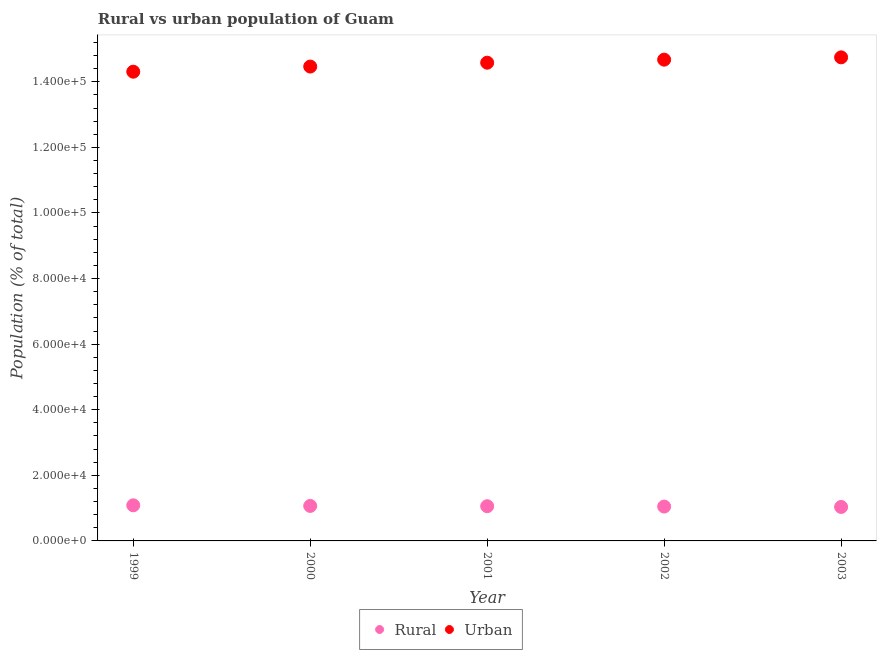What is the urban population density in 2001?
Give a very brief answer. 1.46e+05. Across all years, what is the maximum rural population density?
Ensure brevity in your answer.  1.09e+04. Across all years, what is the minimum urban population density?
Give a very brief answer. 1.43e+05. In which year was the urban population density maximum?
Make the answer very short. 2003. What is the total rural population density in the graph?
Make the answer very short. 5.30e+04. What is the difference between the rural population density in 2000 and that in 2002?
Offer a very short reply. 191. What is the difference between the rural population density in 2003 and the urban population density in 2001?
Your answer should be very brief. -1.35e+05. What is the average rural population density per year?
Offer a very short reply. 1.06e+04. In the year 2000, what is the difference between the urban population density and rural population density?
Your answer should be compact. 1.34e+05. In how many years, is the urban population density greater than 144000 %?
Offer a very short reply. 4. What is the ratio of the rural population density in 1999 to that in 2003?
Ensure brevity in your answer.  1.05. What is the difference between the highest and the second highest urban population density?
Provide a succinct answer. 703. What is the difference between the highest and the lowest urban population density?
Offer a very short reply. 4371. Is the sum of the urban population density in 1999 and 2003 greater than the maximum rural population density across all years?
Your response must be concise. Yes. Does the urban population density monotonically increase over the years?
Your answer should be very brief. Yes. Is the rural population density strictly less than the urban population density over the years?
Provide a succinct answer. Yes. How many years are there in the graph?
Make the answer very short. 5. What is the difference between two consecutive major ticks on the Y-axis?
Make the answer very short. 2.00e+04. Does the graph contain any zero values?
Make the answer very short. No. How are the legend labels stacked?
Offer a very short reply. Horizontal. What is the title of the graph?
Your answer should be very brief. Rural vs urban population of Guam. What is the label or title of the X-axis?
Give a very brief answer. Year. What is the label or title of the Y-axis?
Offer a very short reply. Population (% of total). What is the Population (% of total) in Rural in 1999?
Your answer should be very brief. 1.09e+04. What is the Population (% of total) of Urban in 1999?
Ensure brevity in your answer.  1.43e+05. What is the Population (% of total) in Rural in 2000?
Give a very brief answer. 1.07e+04. What is the Population (% of total) of Urban in 2000?
Give a very brief answer. 1.45e+05. What is the Population (% of total) of Rural in 2001?
Give a very brief answer. 1.06e+04. What is the Population (% of total) of Urban in 2001?
Provide a succinct answer. 1.46e+05. What is the Population (% of total) in Rural in 2002?
Provide a short and direct response. 1.05e+04. What is the Population (% of total) of Urban in 2002?
Ensure brevity in your answer.  1.47e+05. What is the Population (% of total) of Rural in 2003?
Ensure brevity in your answer.  1.04e+04. What is the Population (% of total) of Urban in 2003?
Your response must be concise. 1.47e+05. Across all years, what is the maximum Population (% of total) of Rural?
Offer a terse response. 1.09e+04. Across all years, what is the maximum Population (% of total) in Urban?
Provide a short and direct response. 1.47e+05. Across all years, what is the minimum Population (% of total) in Rural?
Give a very brief answer. 1.04e+04. Across all years, what is the minimum Population (% of total) of Urban?
Offer a very short reply. 1.43e+05. What is the total Population (% of total) in Rural in the graph?
Offer a very short reply. 5.30e+04. What is the total Population (% of total) in Urban in the graph?
Make the answer very short. 7.28e+05. What is the difference between the Population (% of total) of Rural in 1999 and that in 2000?
Make the answer very short. 187. What is the difference between the Population (% of total) in Urban in 1999 and that in 2000?
Make the answer very short. -1564. What is the difference between the Population (% of total) of Rural in 1999 and that in 2001?
Make the answer very short. 275. What is the difference between the Population (% of total) in Urban in 1999 and that in 2001?
Offer a terse response. -2741. What is the difference between the Population (% of total) of Rural in 1999 and that in 2002?
Provide a short and direct response. 378. What is the difference between the Population (% of total) of Urban in 1999 and that in 2002?
Ensure brevity in your answer.  -3668. What is the difference between the Population (% of total) of Rural in 1999 and that in 2003?
Your response must be concise. 499. What is the difference between the Population (% of total) of Urban in 1999 and that in 2003?
Provide a succinct answer. -4371. What is the difference between the Population (% of total) in Rural in 2000 and that in 2001?
Keep it short and to the point. 88. What is the difference between the Population (% of total) in Urban in 2000 and that in 2001?
Give a very brief answer. -1177. What is the difference between the Population (% of total) of Rural in 2000 and that in 2002?
Offer a terse response. 191. What is the difference between the Population (% of total) of Urban in 2000 and that in 2002?
Your answer should be compact. -2104. What is the difference between the Population (% of total) of Rural in 2000 and that in 2003?
Keep it short and to the point. 312. What is the difference between the Population (% of total) of Urban in 2000 and that in 2003?
Ensure brevity in your answer.  -2807. What is the difference between the Population (% of total) of Rural in 2001 and that in 2002?
Ensure brevity in your answer.  103. What is the difference between the Population (% of total) of Urban in 2001 and that in 2002?
Offer a terse response. -927. What is the difference between the Population (% of total) of Rural in 2001 and that in 2003?
Give a very brief answer. 224. What is the difference between the Population (% of total) in Urban in 2001 and that in 2003?
Your response must be concise. -1630. What is the difference between the Population (% of total) in Rural in 2002 and that in 2003?
Your answer should be very brief. 121. What is the difference between the Population (% of total) of Urban in 2002 and that in 2003?
Make the answer very short. -703. What is the difference between the Population (% of total) in Rural in 1999 and the Population (% of total) in Urban in 2000?
Give a very brief answer. -1.34e+05. What is the difference between the Population (% of total) of Rural in 1999 and the Population (% of total) of Urban in 2001?
Keep it short and to the point. -1.35e+05. What is the difference between the Population (% of total) of Rural in 1999 and the Population (% of total) of Urban in 2002?
Your answer should be very brief. -1.36e+05. What is the difference between the Population (% of total) of Rural in 1999 and the Population (% of total) of Urban in 2003?
Offer a very short reply. -1.37e+05. What is the difference between the Population (% of total) of Rural in 2000 and the Population (% of total) of Urban in 2001?
Your answer should be compact. -1.35e+05. What is the difference between the Population (% of total) of Rural in 2000 and the Population (% of total) of Urban in 2002?
Provide a succinct answer. -1.36e+05. What is the difference between the Population (% of total) of Rural in 2000 and the Population (% of total) of Urban in 2003?
Provide a short and direct response. -1.37e+05. What is the difference between the Population (% of total) of Rural in 2001 and the Population (% of total) of Urban in 2002?
Make the answer very short. -1.36e+05. What is the difference between the Population (% of total) of Rural in 2001 and the Population (% of total) of Urban in 2003?
Your answer should be compact. -1.37e+05. What is the difference between the Population (% of total) in Rural in 2002 and the Population (% of total) in Urban in 2003?
Make the answer very short. -1.37e+05. What is the average Population (% of total) of Rural per year?
Your answer should be compact. 1.06e+04. What is the average Population (% of total) of Urban per year?
Make the answer very short. 1.46e+05. In the year 1999, what is the difference between the Population (% of total) in Rural and Population (% of total) in Urban?
Your answer should be compact. -1.32e+05. In the year 2000, what is the difference between the Population (% of total) in Rural and Population (% of total) in Urban?
Keep it short and to the point. -1.34e+05. In the year 2001, what is the difference between the Population (% of total) in Rural and Population (% of total) in Urban?
Offer a very short reply. -1.35e+05. In the year 2002, what is the difference between the Population (% of total) of Rural and Population (% of total) of Urban?
Provide a short and direct response. -1.36e+05. In the year 2003, what is the difference between the Population (% of total) in Rural and Population (% of total) in Urban?
Your response must be concise. -1.37e+05. What is the ratio of the Population (% of total) in Rural in 1999 to that in 2000?
Offer a terse response. 1.02. What is the ratio of the Population (% of total) in Urban in 1999 to that in 2000?
Offer a terse response. 0.99. What is the ratio of the Population (% of total) of Rural in 1999 to that in 2001?
Offer a terse response. 1.03. What is the ratio of the Population (% of total) of Urban in 1999 to that in 2001?
Provide a succinct answer. 0.98. What is the ratio of the Population (% of total) of Rural in 1999 to that in 2002?
Keep it short and to the point. 1.04. What is the ratio of the Population (% of total) of Rural in 1999 to that in 2003?
Your answer should be very brief. 1.05. What is the ratio of the Population (% of total) of Urban in 1999 to that in 2003?
Offer a very short reply. 0.97. What is the ratio of the Population (% of total) of Rural in 2000 to that in 2001?
Provide a short and direct response. 1.01. What is the ratio of the Population (% of total) of Rural in 2000 to that in 2002?
Provide a short and direct response. 1.02. What is the ratio of the Population (% of total) in Urban in 2000 to that in 2002?
Provide a short and direct response. 0.99. What is the ratio of the Population (% of total) of Rural in 2000 to that in 2003?
Provide a succinct answer. 1.03. What is the ratio of the Population (% of total) of Rural in 2001 to that in 2002?
Offer a very short reply. 1.01. What is the ratio of the Population (% of total) in Urban in 2001 to that in 2002?
Provide a succinct answer. 0.99. What is the ratio of the Population (% of total) of Rural in 2001 to that in 2003?
Offer a terse response. 1.02. What is the ratio of the Population (% of total) in Urban in 2001 to that in 2003?
Keep it short and to the point. 0.99. What is the ratio of the Population (% of total) in Rural in 2002 to that in 2003?
Ensure brevity in your answer.  1.01. What is the difference between the highest and the second highest Population (% of total) in Rural?
Keep it short and to the point. 187. What is the difference between the highest and the second highest Population (% of total) in Urban?
Provide a short and direct response. 703. What is the difference between the highest and the lowest Population (% of total) of Rural?
Make the answer very short. 499. What is the difference between the highest and the lowest Population (% of total) of Urban?
Ensure brevity in your answer.  4371. 